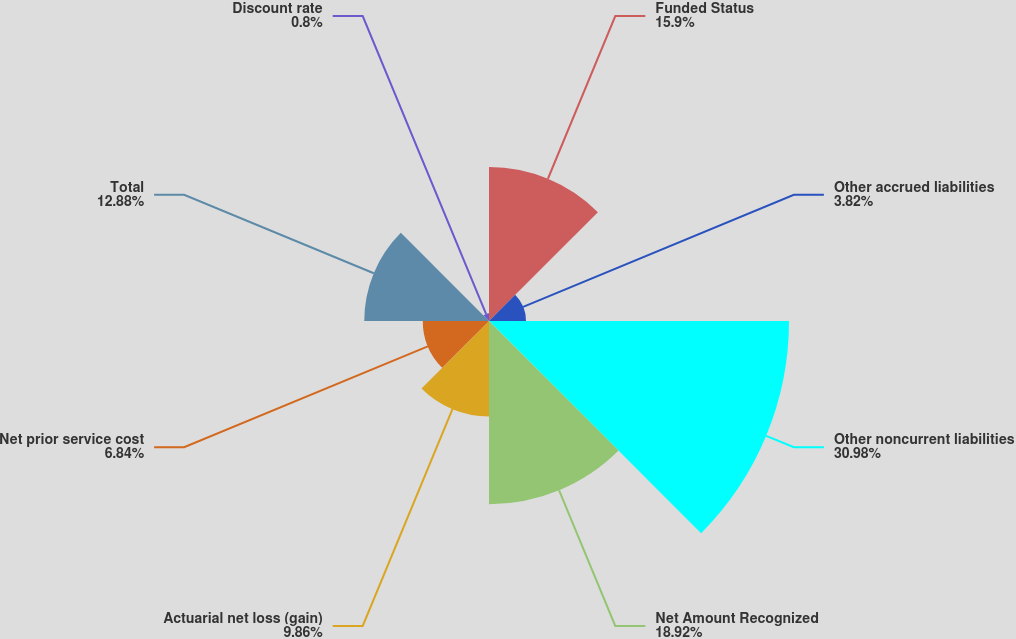Convert chart to OTSL. <chart><loc_0><loc_0><loc_500><loc_500><pie_chart><fcel>Funded Status<fcel>Other accrued liabilities<fcel>Other noncurrent liabilities<fcel>Net Amount Recognized<fcel>Actuarial net loss (gain)<fcel>Net prior service cost<fcel>Total<fcel>Discount rate<nl><fcel>15.9%<fcel>3.82%<fcel>30.98%<fcel>18.92%<fcel>9.86%<fcel>6.84%<fcel>12.88%<fcel>0.8%<nl></chart> 